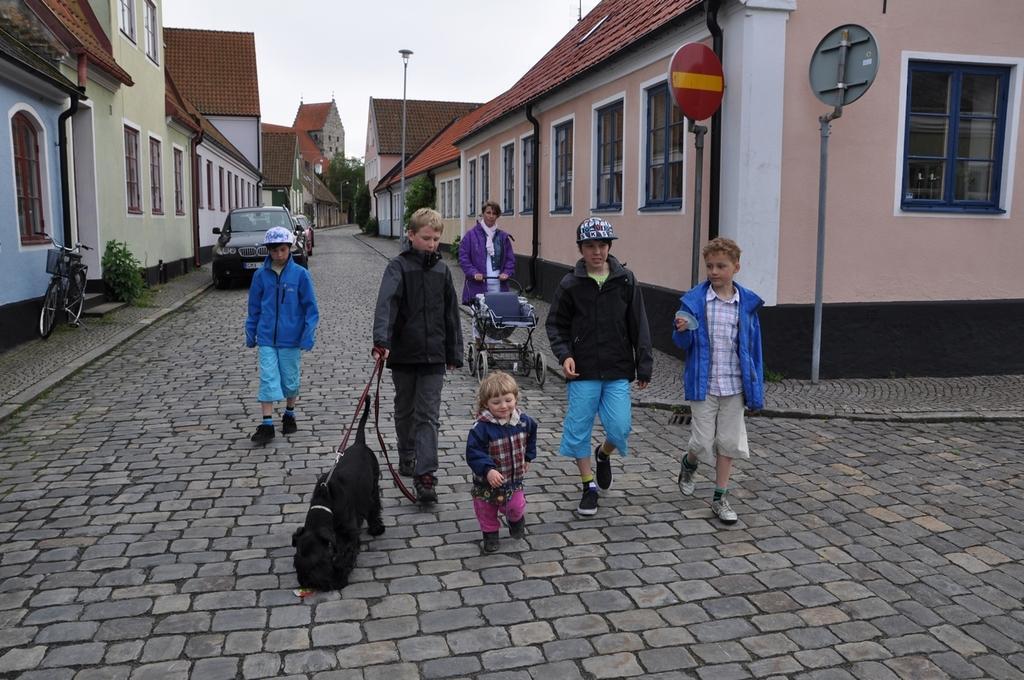In one or two sentences, can you explain what this image depicts? In this image I can see group of people walking. In front the person is wearing black color dress and holding the dog belt and the dog is in black color. Background I can see few vehicles, buildings in white, brown and cream color and I can also see the light pole, few trees in green color and the sky is in white color. 